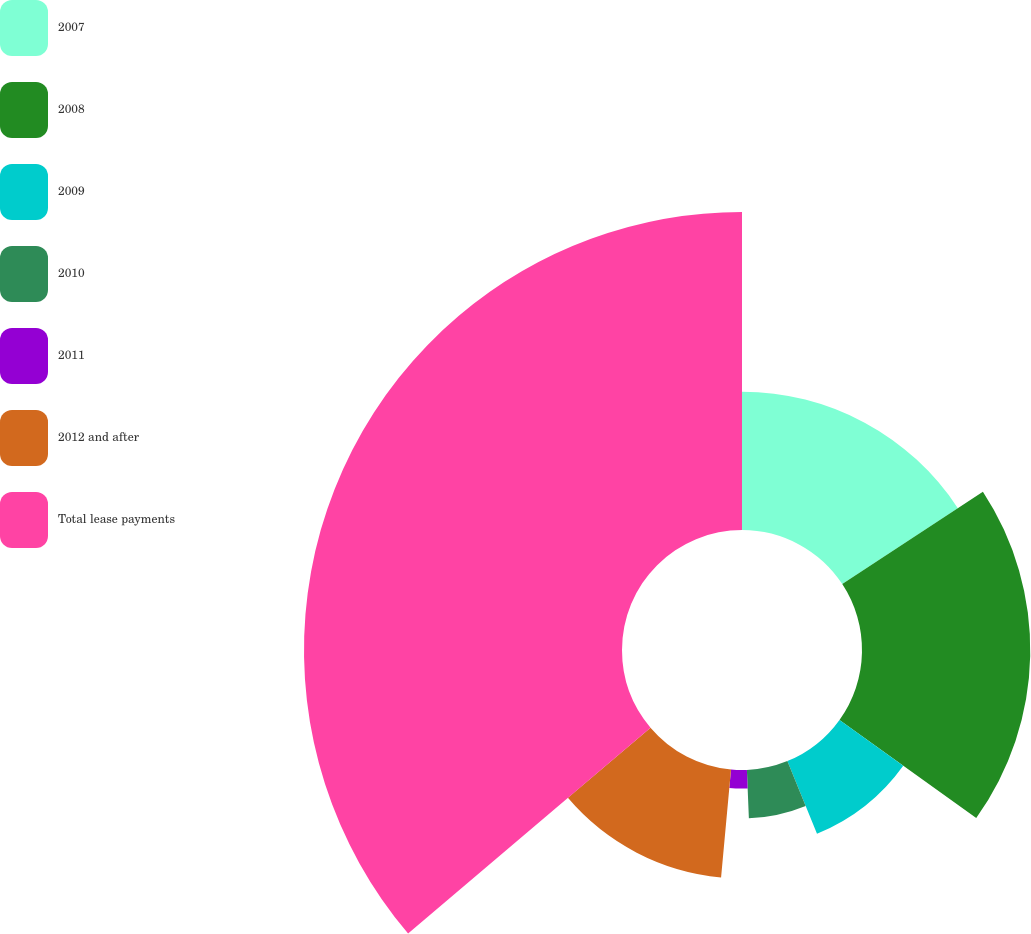Convert chart to OTSL. <chart><loc_0><loc_0><loc_500><loc_500><pie_chart><fcel>2007<fcel>2008<fcel>2009<fcel>2010<fcel>2011<fcel>2012 and after<fcel>Total lease payments<nl><fcel>15.75%<fcel>19.16%<fcel>8.93%<fcel>5.52%<fcel>2.11%<fcel>12.34%<fcel>36.21%<nl></chart> 